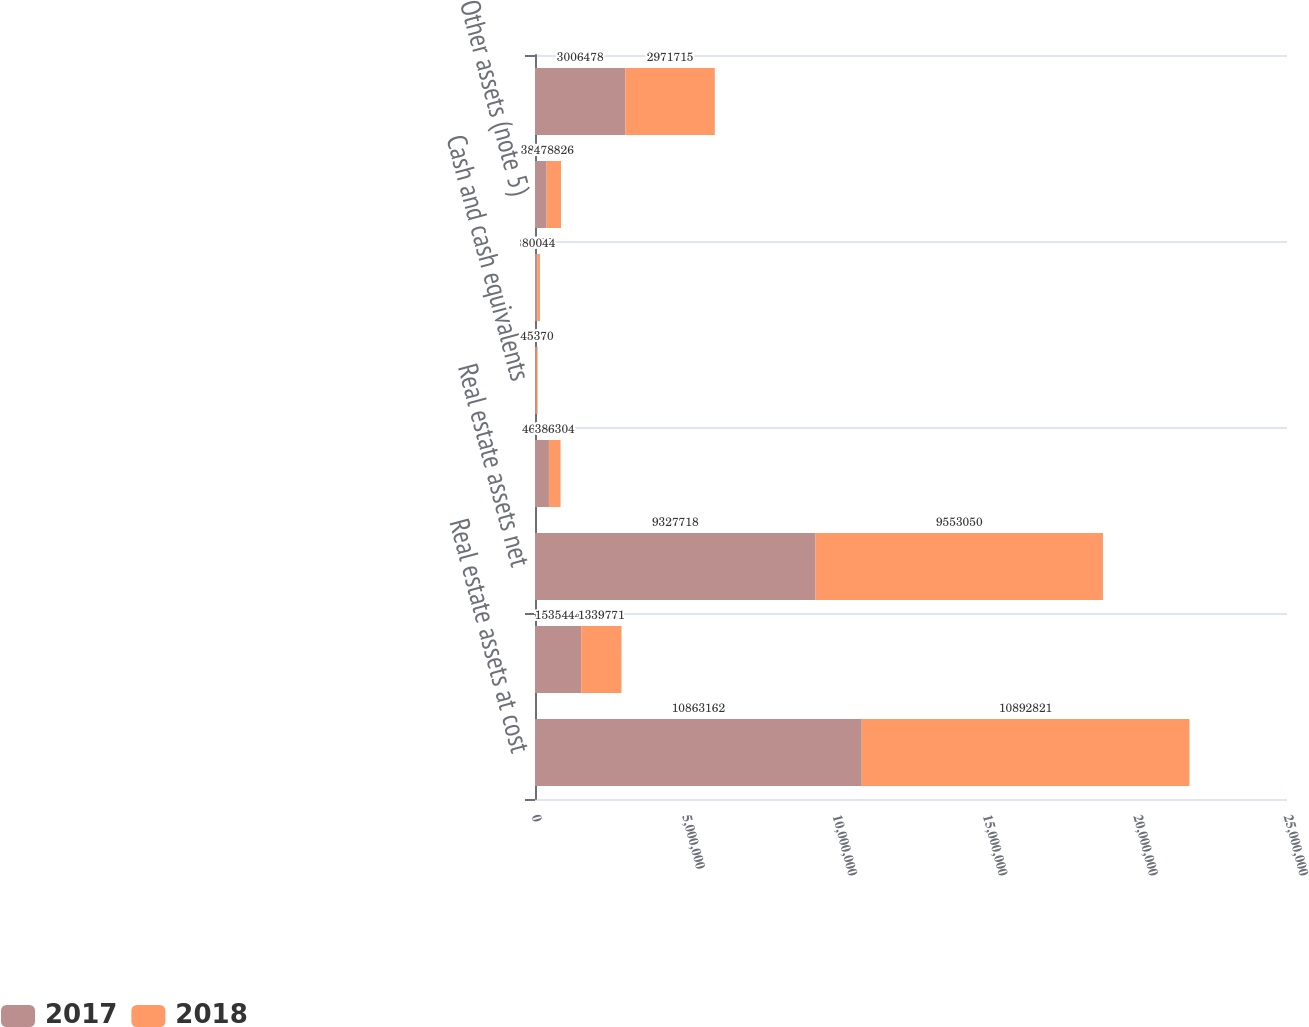Convert chart to OTSL. <chart><loc_0><loc_0><loc_500><loc_500><stacked_bar_chart><ecel><fcel>Real estate assets at cost<fcel>Less accumulated depreciation<fcel>Real estate assets net<fcel>Investments in real estate<fcel>Cash and cash equivalents<fcel>Tenant and other receivables<fcel>Other assets (note 5)<fcel>Notes payable (note 8)<nl><fcel>2017<fcel>1.08632e+07<fcel>1.53544e+06<fcel>9.32772e+06<fcel>463001<fcel>42532<fcel>84983<fcel>387069<fcel>3.00648e+06<nl><fcel>2018<fcel>1.08928e+07<fcel>1.33977e+06<fcel>9.55305e+06<fcel>386304<fcel>45370<fcel>80044<fcel>478826<fcel>2.97172e+06<nl></chart> 